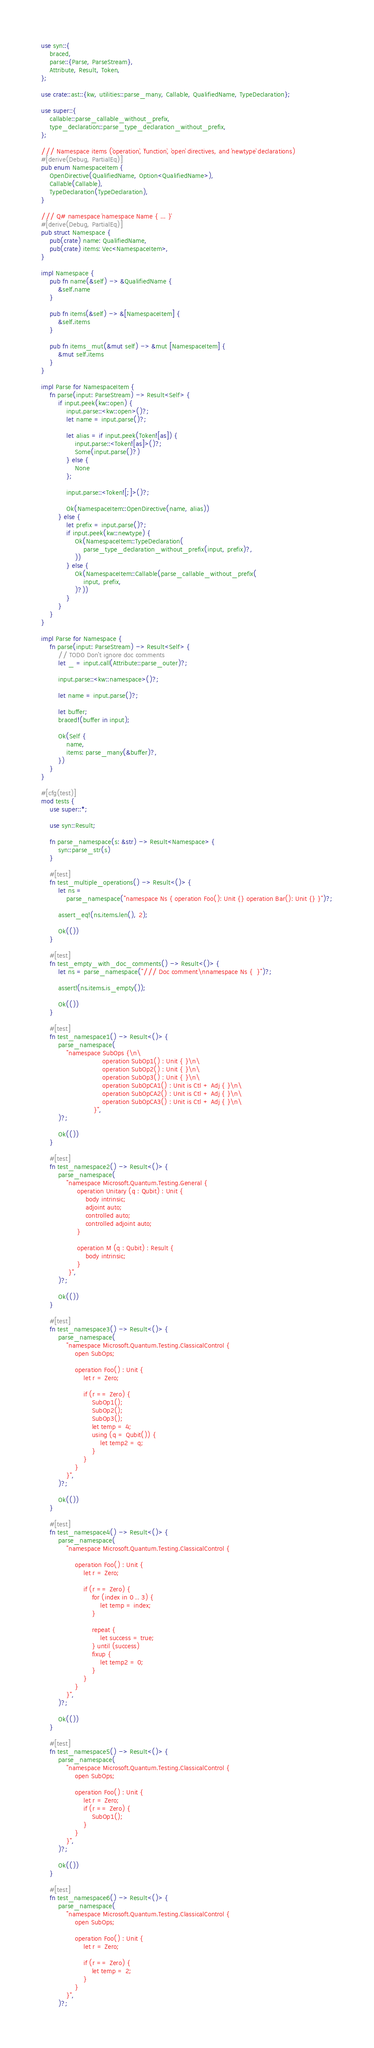<code> <loc_0><loc_0><loc_500><loc_500><_Rust_>use syn::{
    braced,
    parse::{Parse, ParseStream},
    Attribute, Result, Token,
};

use crate::ast::{kw, utilities::parse_many, Callable, QualifiedName, TypeDeclaration};

use super::{
    callable::parse_callable_without_prefix,
    type_declaration::parse_type_declaration_without_prefix,
};

/// Namespace items (`operation`, `function`, `open` directives, and `newtype` declarations)
#[derive(Debug, PartialEq)]
pub enum NamespaceItem {
    OpenDirective(QualifiedName, Option<QualifiedName>),
    Callable(Callable),
    TypeDeclaration(TypeDeclaration),
}

/// Q# namespace `namespace Name { ... }`
#[derive(Debug, PartialEq)]
pub struct Namespace {
    pub(crate) name: QualifiedName,
    pub(crate) items: Vec<NamespaceItem>,
}

impl Namespace {
    pub fn name(&self) -> &QualifiedName {
        &self.name
    }

    pub fn items(&self) -> &[NamespaceItem] {
        &self.items
    }

    pub fn items_mut(&mut self) -> &mut [NamespaceItem] {
        &mut self.items
    }
}

impl Parse for NamespaceItem {
    fn parse(input: ParseStream) -> Result<Self> {
        if input.peek(kw::open) {
            input.parse::<kw::open>()?;
            let name = input.parse()?;

            let alias = if input.peek(Token![as]) {
                input.parse::<Token![as]>()?;
                Some(input.parse()?)
            } else {
                None
            };

            input.parse::<Token![;]>()?;

            Ok(NamespaceItem::OpenDirective(name, alias))
        } else {
            let prefix = input.parse()?;
            if input.peek(kw::newtype) {
                Ok(NamespaceItem::TypeDeclaration(
                    parse_type_declaration_without_prefix(input, prefix)?,
                ))
            } else {
                Ok(NamespaceItem::Callable(parse_callable_without_prefix(
                    input, prefix,
                )?))
            }
        }
    }
}

impl Parse for Namespace {
    fn parse(input: ParseStream) -> Result<Self> {
        // TODO Don't ignore doc comments
        let _ = input.call(Attribute::parse_outer)?;

        input.parse::<kw::namespace>()?;

        let name = input.parse()?;

        let buffer;
        braced!(buffer in input);

        Ok(Self {
            name,
            items: parse_many(&buffer)?,
        })
    }
}

#[cfg(test)]
mod tests {
    use super::*;

    use syn::Result;

    fn parse_namespace(s: &str) -> Result<Namespace> {
        syn::parse_str(s)
    }

    #[test]
    fn test_multiple_operations() -> Result<()> {
        let ns =
            parse_namespace("namespace Ns { operation Foo(): Unit {} operation Bar(): Unit {} }")?;

        assert_eq!(ns.items.len(), 2);

        Ok(())
    }

    #[test]
    fn test_empty_with_doc_comments() -> Result<()> {
        let ns = parse_namespace("/// Doc comment\nnamespace Ns {  }")?;

        assert!(ns.items.is_empty());

        Ok(())
    }

    #[test]
    fn test_namespace1() -> Result<()> {
        parse_namespace(
            "namespace SubOps {\n\
                             operation SubOp1() : Unit { }\n\
                             operation SubOp2() : Unit { }\n\
                             operation SubOp3() : Unit { }\n\
                             operation SubOpCA1() : Unit is Ctl + Adj { }\n\
                             operation SubOpCA2() : Unit is Ctl + Adj { }\n\
                             operation SubOpCA3() : Unit is Ctl + Adj { }\n\
                         }",
        )?;

        Ok(())
    }

    #[test]
    fn test_namespace2() -> Result<()> {
        parse_namespace(
            "namespace Microsoft.Quantum.Testing.General {
                 operation Unitary (q : Qubit) : Unit {
                     body intrinsic;
                     adjoint auto;
                     controlled auto;
                     controlled adjoint auto;
                 }

                 operation M (q : Qubit) : Result {
                     body intrinsic;
                 }
             }",
        )?;

        Ok(())
    }

    #[test]
    fn test_namespace3() -> Result<()> {
        parse_namespace(
            "namespace Microsoft.Quantum.Testing.ClassicalControl {
                open SubOps;
            
                operation Foo() : Unit {
                    let r = Zero;
            
                    if (r == Zero) {
                        SubOp1();
                        SubOp2();
                        SubOp3();
                        let temp = 4;
                        using (q = Qubit()) {
                            let temp2 = q;
                        }
                    }
                }
            }",
        )?;

        Ok(())
    }

    #[test]
    fn test_namespace4() -> Result<()> {
        parse_namespace(
            "namespace Microsoft.Quantum.Testing.ClassicalControl {

                operation Foo() : Unit {
                    let r = Zero;
            
                    if (r == Zero) {
                        for (index in 0 .. 3) {
                            let temp = index;
                        }
            
                        repeat {
                            let success = true;
                        } until (success)
                        fixup {
                            let temp2 = 0;
                        }
                    }
                }
            }",
        )?;

        Ok(())
    }

    #[test]
    fn test_namespace5() -> Result<()> {
        parse_namespace(
            "namespace Microsoft.Quantum.Testing.ClassicalControl {
                open SubOps;
            
                operation Foo() : Unit {
                    let r = Zero;
                    if (r == Zero) {
                        SubOp1();
                    }
                }
            }",
        )?;

        Ok(())
    }

    #[test]
    fn test_namespace6() -> Result<()> {
        parse_namespace(
            "namespace Microsoft.Quantum.Testing.ClassicalControl {
                open SubOps;
            
                operation Foo() : Unit {
                    let r = Zero;
            
                    if (r == Zero) {
                        let temp = 2;
                    }
                }
            }",
        )?;
</code> 